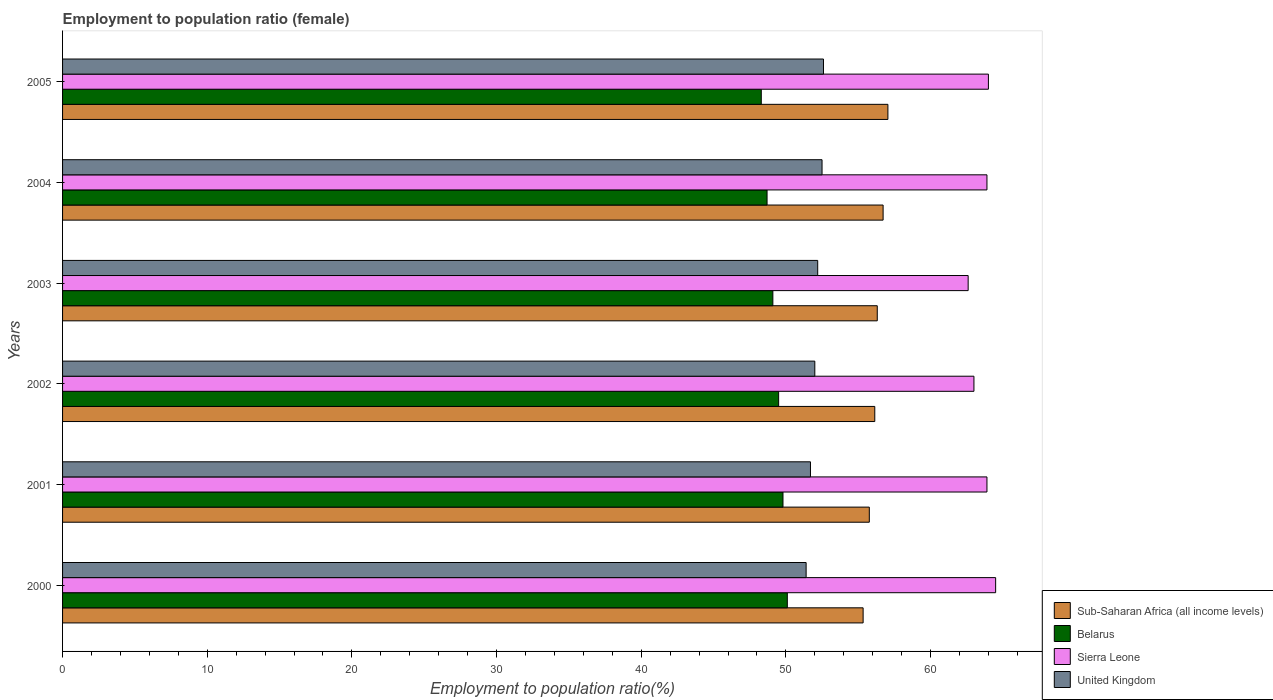Are the number of bars per tick equal to the number of legend labels?
Offer a terse response. Yes. What is the label of the 2nd group of bars from the top?
Your answer should be very brief. 2004. In how many cases, is the number of bars for a given year not equal to the number of legend labels?
Offer a very short reply. 0. What is the employment to population ratio in United Kingdom in 2004?
Give a very brief answer. 52.5. Across all years, what is the maximum employment to population ratio in United Kingdom?
Keep it short and to the point. 52.6. Across all years, what is the minimum employment to population ratio in Belarus?
Your answer should be very brief. 48.3. In which year was the employment to population ratio in Sierra Leone maximum?
Offer a very short reply. 2000. In which year was the employment to population ratio in United Kingdom minimum?
Offer a very short reply. 2000. What is the total employment to population ratio in Sierra Leone in the graph?
Keep it short and to the point. 381.9. What is the difference between the employment to population ratio in Belarus in 2003 and that in 2004?
Your response must be concise. 0.4. What is the difference between the employment to population ratio in United Kingdom in 2004 and the employment to population ratio in Sub-Saharan Africa (all income levels) in 2003?
Provide a succinct answer. -3.82. What is the average employment to population ratio in Sub-Saharan Africa (all income levels) per year?
Keep it short and to the point. 56.22. In the year 2001, what is the difference between the employment to population ratio in Sub-Saharan Africa (all income levels) and employment to population ratio in Sierra Leone?
Your response must be concise. -8.13. What is the ratio of the employment to population ratio in United Kingdom in 2003 to that in 2005?
Provide a short and direct response. 0.99. Is the employment to population ratio in Belarus in 2004 less than that in 2005?
Your answer should be very brief. No. What is the difference between the highest and the second highest employment to population ratio in Sub-Saharan Africa (all income levels)?
Offer a terse response. 0.33. What is the difference between the highest and the lowest employment to population ratio in United Kingdom?
Ensure brevity in your answer.  1.2. Is the sum of the employment to population ratio in Sub-Saharan Africa (all income levels) in 2000 and 2002 greater than the maximum employment to population ratio in United Kingdom across all years?
Your response must be concise. Yes. Is it the case that in every year, the sum of the employment to population ratio in Belarus and employment to population ratio in Sierra Leone is greater than the sum of employment to population ratio in Sub-Saharan Africa (all income levels) and employment to population ratio in United Kingdom?
Keep it short and to the point. No. What does the 2nd bar from the bottom in 2002 represents?
Your answer should be very brief. Belarus. Is it the case that in every year, the sum of the employment to population ratio in United Kingdom and employment to population ratio in Sub-Saharan Africa (all income levels) is greater than the employment to population ratio in Belarus?
Give a very brief answer. Yes. How many years are there in the graph?
Offer a terse response. 6. What is the difference between two consecutive major ticks on the X-axis?
Your response must be concise. 10. Are the values on the major ticks of X-axis written in scientific E-notation?
Offer a terse response. No. Does the graph contain grids?
Keep it short and to the point. No. What is the title of the graph?
Provide a succinct answer. Employment to population ratio (female). What is the label or title of the X-axis?
Your response must be concise. Employment to population ratio(%). What is the label or title of the Y-axis?
Offer a very short reply. Years. What is the Employment to population ratio(%) in Sub-Saharan Africa (all income levels) in 2000?
Provide a succinct answer. 55.34. What is the Employment to population ratio(%) in Belarus in 2000?
Ensure brevity in your answer.  50.1. What is the Employment to population ratio(%) of Sierra Leone in 2000?
Provide a short and direct response. 64.5. What is the Employment to population ratio(%) of United Kingdom in 2000?
Make the answer very short. 51.4. What is the Employment to population ratio(%) of Sub-Saharan Africa (all income levels) in 2001?
Ensure brevity in your answer.  55.77. What is the Employment to population ratio(%) of Belarus in 2001?
Make the answer very short. 49.8. What is the Employment to population ratio(%) in Sierra Leone in 2001?
Provide a succinct answer. 63.9. What is the Employment to population ratio(%) of United Kingdom in 2001?
Offer a terse response. 51.7. What is the Employment to population ratio(%) of Sub-Saharan Africa (all income levels) in 2002?
Make the answer very short. 56.15. What is the Employment to population ratio(%) in Belarus in 2002?
Your response must be concise. 49.5. What is the Employment to population ratio(%) of United Kingdom in 2002?
Offer a terse response. 52. What is the Employment to population ratio(%) in Sub-Saharan Africa (all income levels) in 2003?
Your response must be concise. 56.32. What is the Employment to population ratio(%) in Belarus in 2003?
Make the answer very short. 49.1. What is the Employment to population ratio(%) in Sierra Leone in 2003?
Your answer should be compact. 62.6. What is the Employment to population ratio(%) of United Kingdom in 2003?
Your response must be concise. 52.2. What is the Employment to population ratio(%) of Sub-Saharan Africa (all income levels) in 2004?
Your answer should be very brief. 56.72. What is the Employment to population ratio(%) of Belarus in 2004?
Keep it short and to the point. 48.7. What is the Employment to population ratio(%) in Sierra Leone in 2004?
Make the answer very short. 63.9. What is the Employment to population ratio(%) in United Kingdom in 2004?
Your answer should be very brief. 52.5. What is the Employment to population ratio(%) of Sub-Saharan Africa (all income levels) in 2005?
Your answer should be very brief. 57.05. What is the Employment to population ratio(%) in Belarus in 2005?
Offer a very short reply. 48.3. What is the Employment to population ratio(%) in United Kingdom in 2005?
Your response must be concise. 52.6. Across all years, what is the maximum Employment to population ratio(%) in Sub-Saharan Africa (all income levels)?
Offer a terse response. 57.05. Across all years, what is the maximum Employment to population ratio(%) of Belarus?
Make the answer very short. 50.1. Across all years, what is the maximum Employment to population ratio(%) in Sierra Leone?
Offer a terse response. 64.5. Across all years, what is the maximum Employment to population ratio(%) in United Kingdom?
Keep it short and to the point. 52.6. Across all years, what is the minimum Employment to population ratio(%) of Sub-Saharan Africa (all income levels)?
Make the answer very short. 55.34. Across all years, what is the minimum Employment to population ratio(%) of Belarus?
Your response must be concise. 48.3. Across all years, what is the minimum Employment to population ratio(%) of Sierra Leone?
Offer a terse response. 62.6. Across all years, what is the minimum Employment to population ratio(%) of United Kingdom?
Give a very brief answer. 51.4. What is the total Employment to population ratio(%) in Sub-Saharan Africa (all income levels) in the graph?
Your answer should be very brief. 337.35. What is the total Employment to population ratio(%) in Belarus in the graph?
Give a very brief answer. 295.5. What is the total Employment to population ratio(%) of Sierra Leone in the graph?
Offer a very short reply. 381.9. What is the total Employment to population ratio(%) of United Kingdom in the graph?
Your response must be concise. 312.4. What is the difference between the Employment to population ratio(%) of Sub-Saharan Africa (all income levels) in 2000 and that in 2001?
Make the answer very short. -0.43. What is the difference between the Employment to population ratio(%) of Sub-Saharan Africa (all income levels) in 2000 and that in 2002?
Ensure brevity in your answer.  -0.81. What is the difference between the Employment to population ratio(%) of Belarus in 2000 and that in 2002?
Your answer should be compact. 0.6. What is the difference between the Employment to population ratio(%) of United Kingdom in 2000 and that in 2002?
Provide a succinct answer. -0.6. What is the difference between the Employment to population ratio(%) of Sub-Saharan Africa (all income levels) in 2000 and that in 2003?
Offer a terse response. -0.98. What is the difference between the Employment to population ratio(%) in Sierra Leone in 2000 and that in 2003?
Your answer should be compact. 1.9. What is the difference between the Employment to population ratio(%) of United Kingdom in 2000 and that in 2003?
Give a very brief answer. -0.8. What is the difference between the Employment to population ratio(%) in Sub-Saharan Africa (all income levels) in 2000 and that in 2004?
Your answer should be very brief. -1.38. What is the difference between the Employment to population ratio(%) of Belarus in 2000 and that in 2004?
Offer a very short reply. 1.4. What is the difference between the Employment to population ratio(%) in Sierra Leone in 2000 and that in 2004?
Your response must be concise. 0.6. What is the difference between the Employment to population ratio(%) of United Kingdom in 2000 and that in 2004?
Offer a terse response. -1.1. What is the difference between the Employment to population ratio(%) in Sub-Saharan Africa (all income levels) in 2000 and that in 2005?
Your response must be concise. -1.71. What is the difference between the Employment to population ratio(%) of Belarus in 2000 and that in 2005?
Provide a short and direct response. 1.8. What is the difference between the Employment to population ratio(%) of Sierra Leone in 2000 and that in 2005?
Offer a terse response. 0.5. What is the difference between the Employment to population ratio(%) of United Kingdom in 2000 and that in 2005?
Provide a succinct answer. -1.2. What is the difference between the Employment to population ratio(%) in Sub-Saharan Africa (all income levels) in 2001 and that in 2002?
Offer a very short reply. -0.38. What is the difference between the Employment to population ratio(%) of Sierra Leone in 2001 and that in 2002?
Offer a terse response. 0.9. What is the difference between the Employment to population ratio(%) of Sub-Saharan Africa (all income levels) in 2001 and that in 2003?
Provide a succinct answer. -0.55. What is the difference between the Employment to population ratio(%) of Sierra Leone in 2001 and that in 2003?
Offer a terse response. 1.3. What is the difference between the Employment to population ratio(%) in United Kingdom in 2001 and that in 2003?
Offer a very short reply. -0.5. What is the difference between the Employment to population ratio(%) of Sub-Saharan Africa (all income levels) in 2001 and that in 2004?
Offer a terse response. -0.95. What is the difference between the Employment to population ratio(%) of Sub-Saharan Africa (all income levels) in 2001 and that in 2005?
Provide a short and direct response. -1.29. What is the difference between the Employment to population ratio(%) in Sierra Leone in 2001 and that in 2005?
Provide a short and direct response. -0.1. What is the difference between the Employment to population ratio(%) in Sub-Saharan Africa (all income levels) in 2002 and that in 2003?
Your answer should be very brief. -0.17. What is the difference between the Employment to population ratio(%) of Belarus in 2002 and that in 2003?
Ensure brevity in your answer.  0.4. What is the difference between the Employment to population ratio(%) in United Kingdom in 2002 and that in 2003?
Give a very brief answer. -0.2. What is the difference between the Employment to population ratio(%) in Sub-Saharan Africa (all income levels) in 2002 and that in 2004?
Offer a very short reply. -0.58. What is the difference between the Employment to population ratio(%) in Sierra Leone in 2002 and that in 2004?
Give a very brief answer. -0.9. What is the difference between the Employment to population ratio(%) of United Kingdom in 2002 and that in 2004?
Make the answer very short. -0.5. What is the difference between the Employment to population ratio(%) of Sub-Saharan Africa (all income levels) in 2002 and that in 2005?
Give a very brief answer. -0.91. What is the difference between the Employment to population ratio(%) in Belarus in 2002 and that in 2005?
Your response must be concise. 1.2. What is the difference between the Employment to population ratio(%) in Sub-Saharan Africa (all income levels) in 2003 and that in 2004?
Make the answer very short. -0.4. What is the difference between the Employment to population ratio(%) in Belarus in 2003 and that in 2004?
Provide a short and direct response. 0.4. What is the difference between the Employment to population ratio(%) in Sub-Saharan Africa (all income levels) in 2003 and that in 2005?
Make the answer very short. -0.74. What is the difference between the Employment to population ratio(%) in Sierra Leone in 2003 and that in 2005?
Ensure brevity in your answer.  -1.4. What is the difference between the Employment to population ratio(%) of Sub-Saharan Africa (all income levels) in 2004 and that in 2005?
Offer a terse response. -0.33. What is the difference between the Employment to population ratio(%) of United Kingdom in 2004 and that in 2005?
Make the answer very short. -0.1. What is the difference between the Employment to population ratio(%) in Sub-Saharan Africa (all income levels) in 2000 and the Employment to population ratio(%) in Belarus in 2001?
Ensure brevity in your answer.  5.54. What is the difference between the Employment to population ratio(%) in Sub-Saharan Africa (all income levels) in 2000 and the Employment to population ratio(%) in Sierra Leone in 2001?
Offer a terse response. -8.56. What is the difference between the Employment to population ratio(%) in Sub-Saharan Africa (all income levels) in 2000 and the Employment to population ratio(%) in United Kingdom in 2001?
Ensure brevity in your answer.  3.64. What is the difference between the Employment to population ratio(%) of Sub-Saharan Africa (all income levels) in 2000 and the Employment to population ratio(%) of Belarus in 2002?
Keep it short and to the point. 5.84. What is the difference between the Employment to population ratio(%) in Sub-Saharan Africa (all income levels) in 2000 and the Employment to population ratio(%) in Sierra Leone in 2002?
Offer a very short reply. -7.66. What is the difference between the Employment to population ratio(%) of Sub-Saharan Africa (all income levels) in 2000 and the Employment to population ratio(%) of United Kingdom in 2002?
Offer a terse response. 3.34. What is the difference between the Employment to population ratio(%) in Belarus in 2000 and the Employment to population ratio(%) in Sierra Leone in 2002?
Keep it short and to the point. -12.9. What is the difference between the Employment to population ratio(%) in Belarus in 2000 and the Employment to population ratio(%) in United Kingdom in 2002?
Give a very brief answer. -1.9. What is the difference between the Employment to population ratio(%) in Sierra Leone in 2000 and the Employment to population ratio(%) in United Kingdom in 2002?
Offer a terse response. 12.5. What is the difference between the Employment to population ratio(%) in Sub-Saharan Africa (all income levels) in 2000 and the Employment to population ratio(%) in Belarus in 2003?
Your answer should be compact. 6.24. What is the difference between the Employment to population ratio(%) in Sub-Saharan Africa (all income levels) in 2000 and the Employment to population ratio(%) in Sierra Leone in 2003?
Your response must be concise. -7.26. What is the difference between the Employment to population ratio(%) in Sub-Saharan Africa (all income levels) in 2000 and the Employment to population ratio(%) in United Kingdom in 2003?
Ensure brevity in your answer.  3.14. What is the difference between the Employment to population ratio(%) in Sierra Leone in 2000 and the Employment to population ratio(%) in United Kingdom in 2003?
Your answer should be very brief. 12.3. What is the difference between the Employment to population ratio(%) of Sub-Saharan Africa (all income levels) in 2000 and the Employment to population ratio(%) of Belarus in 2004?
Ensure brevity in your answer.  6.64. What is the difference between the Employment to population ratio(%) in Sub-Saharan Africa (all income levels) in 2000 and the Employment to population ratio(%) in Sierra Leone in 2004?
Offer a terse response. -8.56. What is the difference between the Employment to population ratio(%) in Sub-Saharan Africa (all income levels) in 2000 and the Employment to population ratio(%) in United Kingdom in 2004?
Make the answer very short. 2.84. What is the difference between the Employment to population ratio(%) in Sub-Saharan Africa (all income levels) in 2000 and the Employment to population ratio(%) in Belarus in 2005?
Offer a very short reply. 7.04. What is the difference between the Employment to population ratio(%) of Sub-Saharan Africa (all income levels) in 2000 and the Employment to population ratio(%) of Sierra Leone in 2005?
Your answer should be very brief. -8.66. What is the difference between the Employment to population ratio(%) in Sub-Saharan Africa (all income levels) in 2000 and the Employment to population ratio(%) in United Kingdom in 2005?
Keep it short and to the point. 2.74. What is the difference between the Employment to population ratio(%) of Belarus in 2000 and the Employment to population ratio(%) of Sierra Leone in 2005?
Your response must be concise. -13.9. What is the difference between the Employment to population ratio(%) of Sierra Leone in 2000 and the Employment to population ratio(%) of United Kingdom in 2005?
Make the answer very short. 11.9. What is the difference between the Employment to population ratio(%) of Sub-Saharan Africa (all income levels) in 2001 and the Employment to population ratio(%) of Belarus in 2002?
Keep it short and to the point. 6.27. What is the difference between the Employment to population ratio(%) of Sub-Saharan Africa (all income levels) in 2001 and the Employment to population ratio(%) of Sierra Leone in 2002?
Ensure brevity in your answer.  -7.23. What is the difference between the Employment to population ratio(%) of Sub-Saharan Africa (all income levels) in 2001 and the Employment to population ratio(%) of United Kingdom in 2002?
Make the answer very short. 3.77. What is the difference between the Employment to population ratio(%) of Belarus in 2001 and the Employment to population ratio(%) of Sierra Leone in 2002?
Offer a terse response. -13.2. What is the difference between the Employment to population ratio(%) in Sierra Leone in 2001 and the Employment to population ratio(%) in United Kingdom in 2002?
Offer a terse response. 11.9. What is the difference between the Employment to population ratio(%) of Sub-Saharan Africa (all income levels) in 2001 and the Employment to population ratio(%) of Belarus in 2003?
Keep it short and to the point. 6.67. What is the difference between the Employment to population ratio(%) in Sub-Saharan Africa (all income levels) in 2001 and the Employment to population ratio(%) in Sierra Leone in 2003?
Your answer should be very brief. -6.83. What is the difference between the Employment to population ratio(%) in Sub-Saharan Africa (all income levels) in 2001 and the Employment to population ratio(%) in United Kingdom in 2003?
Offer a terse response. 3.57. What is the difference between the Employment to population ratio(%) in Belarus in 2001 and the Employment to population ratio(%) in Sierra Leone in 2003?
Provide a short and direct response. -12.8. What is the difference between the Employment to population ratio(%) of Sierra Leone in 2001 and the Employment to population ratio(%) of United Kingdom in 2003?
Offer a terse response. 11.7. What is the difference between the Employment to population ratio(%) in Sub-Saharan Africa (all income levels) in 2001 and the Employment to population ratio(%) in Belarus in 2004?
Provide a succinct answer. 7.07. What is the difference between the Employment to population ratio(%) of Sub-Saharan Africa (all income levels) in 2001 and the Employment to population ratio(%) of Sierra Leone in 2004?
Offer a terse response. -8.13. What is the difference between the Employment to population ratio(%) of Sub-Saharan Africa (all income levels) in 2001 and the Employment to population ratio(%) of United Kingdom in 2004?
Ensure brevity in your answer.  3.27. What is the difference between the Employment to population ratio(%) in Belarus in 2001 and the Employment to population ratio(%) in Sierra Leone in 2004?
Your answer should be very brief. -14.1. What is the difference between the Employment to population ratio(%) in Belarus in 2001 and the Employment to population ratio(%) in United Kingdom in 2004?
Your response must be concise. -2.7. What is the difference between the Employment to population ratio(%) of Sierra Leone in 2001 and the Employment to population ratio(%) of United Kingdom in 2004?
Your answer should be very brief. 11.4. What is the difference between the Employment to population ratio(%) in Sub-Saharan Africa (all income levels) in 2001 and the Employment to population ratio(%) in Belarus in 2005?
Make the answer very short. 7.47. What is the difference between the Employment to population ratio(%) of Sub-Saharan Africa (all income levels) in 2001 and the Employment to population ratio(%) of Sierra Leone in 2005?
Offer a very short reply. -8.23. What is the difference between the Employment to population ratio(%) in Sub-Saharan Africa (all income levels) in 2001 and the Employment to population ratio(%) in United Kingdom in 2005?
Offer a terse response. 3.17. What is the difference between the Employment to population ratio(%) of Belarus in 2001 and the Employment to population ratio(%) of Sierra Leone in 2005?
Make the answer very short. -14.2. What is the difference between the Employment to population ratio(%) in Sub-Saharan Africa (all income levels) in 2002 and the Employment to population ratio(%) in Belarus in 2003?
Your response must be concise. 7.05. What is the difference between the Employment to population ratio(%) of Sub-Saharan Africa (all income levels) in 2002 and the Employment to population ratio(%) of Sierra Leone in 2003?
Offer a terse response. -6.45. What is the difference between the Employment to population ratio(%) in Sub-Saharan Africa (all income levels) in 2002 and the Employment to population ratio(%) in United Kingdom in 2003?
Your answer should be very brief. 3.95. What is the difference between the Employment to population ratio(%) in Sub-Saharan Africa (all income levels) in 2002 and the Employment to population ratio(%) in Belarus in 2004?
Your answer should be compact. 7.45. What is the difference between the Employment to population ratio(%) in Sub-Saharan Africa (all income levels) in 2002 and the Employment to population ratio(%) in Sierra Leone in 2004?
Give a very brief answer. -7.75. What is the difference between the Employment to population ratio(%) of Sub-Saharan Africa (all income levels) in 2002 and the Employment to population ratio(%) of United Kingdom in 2004?
Give a very brief answer. 3.65. What is the difference between the Employment to population ratio(%) in Belarus in 2002 and the Employment to population ratio(%) in Sierra Leone in 2004?
Your answer should be compact. -14.4. What is the difference between the Employment to population ratio(%) of Belarus in 2002 and the Employment to population ratio(%) of United Kingdom in 2004?
Provide a short and direct response. -3. What is the difference between the Employment to population ratio(%) of Sub-Saharan Africa (all income levels) in 2002 and the Employment to population ratio(%) of Belarus in 2005?
Provide a succinct answer. 7.85. What is the difference between the Employment to population ratio(%) in Sub-Saharan Africa (all income levels) in 2002 and the Employment to population ratio(%) in Sierra Leone in 2005?
Provide a succinct answer. -7.85. What is the difference between the Employment to population ratio(%) in Sub-Saharan Africa (all income levels) in 2002 and the Employment to population ratio(%) in United Kingdom in 2005?
Ensure brevity in your answer.  3.55. What is the difference between the Employment to population ratio(%) in Sierra Leone in 2002 and the Employment to population ratio(%) in United Kingdom in 2005?
Your answer should be very brief. 10.4. What is the difference between the Employment to population ratio(%) in Sub-Saharan Africa (all income levels) in 2003 and the Employment to population ratio(%) in Belarus in 2004?
Ensure brevity in your answer.  7.62. What is the difference between the Employment to population ratio(%) in Sub-Saharan Africa (all income levels) in 2003 and the Employment to population ratio(%) in Sierra Leone in 2004?
Provide a succinct answer. -7.58. What is the difference between the Employment to population ratio(%) of Sub-Saharan Africa (all income levels) in 2003 and the Employment to population ratio(%) of United Kingdom in 2004?
Provide a succinct answer. 3.82. What is the difference between the Employment to population ratio(%) of Belarus in 2003 and the Employment to population ratio(%) of Sierra Leone in 2004?
Make the answer very short. -14.8. What is the difference between the Employment to population ratio(%) of Belarus in 2003 and the Employment to population ratio(%) of United Kingdom in 2004?
Ensure brevity in your answer.  -3.4. What is the difference between the Employment to population ratio(%) in Sierra Leone in 2003 and the Employment to population ratio(%) in United Kingdom in 2004?
Keep it short and to the point. 10.1. What is the difference between the Employment to population ratio(%) of Sub-Saharan Africa (all income levels) in 2003 and the Employment to population ratio(%) of Belarus in 2005?
Keep it short and to the point. 8.02. What is the difference between the Employment to population ratio(%) in Sub-Saharan Africa (all income levels) in 2003 and the Employment to population ratio(%) in Sierra Leone in 2005?
Provide a short and direct response. -7.68. What is the difference between the Employment to population ratio(%) in Sub-Saharan Africa (all income levels) in 2003 and the Employment to population ratio(%) in United Kingdom in 2005?
Offer a very short reply. 3.72. What is the difference between the Employment to population ratio(%) of Belarus in 2003 and the Employment to population ratio(%) of Sierra Leone in 2005?
Offer a very short reply. -14.9. What is the difference between the Employment to population ratio(%) in Belarus in 2003 and the Employment to population ratio(%) in United Kingdom in 2005?
Ensure brevity in your answer.  -3.5. What is the difference between the Employment to population ratio(%) in Sub-Saharan Africa (all income levels) in 2004 and the Employment to population ratio(%) in Belarus in 2005?
Make the answer very short. 8.42. What is the difference between the Employment to population ratio(%) in Sub-Saharan Africa (all income levels) in 2004 and the Employment to population ratio(%) in Sierra Leone in 2005?
Offer a very short reply. -7.28. What is the difference between the Employment to population ratio(%) of Sub-Saharan Africa (all income levels) in 2004 and the Employment to population ratio(%) of United Kingdom in 2005?
Your response must be concise. 4.12. What is the difference between the Employment to population ratio(%) in Belarus in 2004 and the Employment to population ratio(%) in Sierra Leone in 2005?
Give a very brief answer. -15.3. What is the difference between the Employment to population ratio(%) in Sierra Leone in 2004 and the Employment to population ratio(%) in United Kingdom in 2005?
Give a very brief answer. 11.3. What is the average Employment to population ratio(%) in Sub-Saharan Africa (all income levels) per year?
Your answer should be compact. 56.22. What is the average Employment to population ratio(%) in Belarus per year?
Keep it short and to the point. 49.25. What is the average Employment to population ratio(%) in Sierra Leone per year?
Provide a short and direct response. 63.65. What is the average Employment to population ratio(%) of United Kingdom per year?
Give a very brief answer. 52.07. In the year 2000, what is the difference between the Employment to population ratio(%) in Sub-Saharan Africa (all income levels) and Employment to population ratio(%) in Belarus?
Keep it short and to the point. 5.24. In the year 2000, what is the difference between the Employment to population ratio(%) in Sub-Saharan Africa (all income levels) and Employment to population ratio(%) in Sierra Leone?
Ensure brevity in your answer.  -9.16. In the year 2000, what is the difference between the Employment to population ratio(%) of Sub-Saharan Africa (all income levels) and Employment to population ratio(%) of United Kingdom?
Your answer should be compact. 3.94. In the year 2000, what is the difference between the Employment to population ratio(%) in Belarus and Employment to population ratio(%) in Sierra Leone?
Your response must be concise. -14.4. In the year 2001, what is the difference between the Employment to population ratio(%) of Sub-Saharan Africa (all income levels) and Employment to population ratio(%) of Belarus?
Give a very brief answer. 5.97. In the year 2001, what is the difference between the Employment to population ratio(%) of Sub-Saharan Africa (all income levels) and Employment to population ratio(%) of Sierra Leone?
Ensure brevity in your answer.  -8.13. In the year 2001, what is the difference between the Employment to population ratio(%) in Sub-Saharan Africa (all income levels) and Employment to population ratio(%) in United Kingdom?
Give a very brief answer. 4.07. In the year 2001, what is the difference between the Employment to population ratio(%) of Belarus and Employment to population ratio(%) of Sierra Leone?
Make the answer very short. -14.1. In the year 2002, what is the difference between the Employment to population ratio(%) in Sub-Saharan Africa (all income levels) and Employment to population ratio(%) in Belarus?
Your answer should be very brief. 6.65. In the year 2002, what is the difference between the Employment to population ratio(%) of Sub-Saharan Africa (all income levels) and Employment to population ratio(%) of Sierra Leone?
Your response must be concise. -6.85. In the year 2002, what is the difference between the Employment to population ratio(%) of Sub-Saharan Africa (all income levels) and Employment to population ratio(%) of United Kingdom?
Your answer should be very brief. 4.15. In the year 2002, what is the difference between the Employment to population ratio(%) in Belarus and Employment to population ratio(%) in Sierra Leone?
Provide a short and direct response. -13.5. In the year 2003, what is the difference between the Employment to population ratio(%) of Sub-Saharan Africa (all income levels) and Employment to population ratio(%) of Belarus?
Offer a very short reply. 7.22. In the year 2003, what is the difference between the Employment to population ratio(%) of Sub-Saharan Africa (all income levels) and Employment to population ratio(%) of Sierra Leone?
Offer a terse response. -6.28. In the year 2003, what is the difference between the Employment to population ratio(%) of Sub-Saharan Africa (all income levels) and Employment to population ratio(%) of United Kingdom?
Your response must be concise. 4.12. In the year 2003, what is the difference between the Employment to population ratio(%) of Belarus and Employment to population ratio(%) of Sierra Leone?
Give a very brief answer. -13.5. In the year 2004, what is the difference between the Employment to population ratio(%) in Sub-Saharan Africa (all income levels) and Employment to population ratio(%) in Belarus?
Your response must be concise. 8.02. In the year 2004, what is the difference between the Employment to population ratio(%) of Sub-Saharan Africa (all income levels) and Employment to population ratio(%) of Sierra Leone?
Keep it short and to the point. -7.18. In the year 2004, what is the difference between the Employment to population ratio(%) of Sub-Saharan Africa (all income levels) and Employment to population ratio(%) of United Kingdom?
Offer a terse response. 4.22. In the year 2004, what is the difference between the Employment to population ratio(%) of Belarus and Employment to population ratio(%) of Sierra Leone?
Provide a succinct answer. -15.2. In the year 2004, what is the difference between the Employment to population ratio(%) in Belarus and Employment to population ratio(%) in United Kingdom?
Provide a succinct answer. -3.8. In the year 2004, what is the difference between the Employment to population ratio(%) of Sierra Leone and Employment to population ratio(%) of United Kingdom?
Offer a terse response. 11.4. In the year 2005, what is the difference between the Employment to population ratio(%) in Sub-Saharan Africa (all income levels) and Employment to population ratio(%) in Belarus?
Offer a terse response. 8.75. In the year 2005, what is the difference between the Employment to population ratio(%) in Sub-Saharan Africa (all income levels) and Employment to population ratio(%) in Sierra Leone?
Keep it short and to the point. -6.95. In the year 2005, what is the difference between the Employment to population ratio(%) of Sub-Saharan Africa (all income levels) and Employment to population ratio(%) of United Kingdom?
Ensure brevity in your answer.  4.45. In the year 2005, what is the difference between the Employment to population ratio(%) in Belarus and Employment to population ratio(%) in Sierra Leone?
Provide a short and direct response. -15.7. In the year 2005, what is the difference between the Employment to population ratio(%) in Belarus and Employment to population ratio(%) in United Kingdom?
Give a very brief answer. -4.3. What is the ratio of the Employment to population ratio(%) in Sub-Saharan Africa (all income levels) in 2000 to that in 2001?
Your response must be concise. 0.99. What is the ratio of the Employment to population ratio(%) of Sierra Leone in 2000 to that in 2001?
Offer a very short reply. 1.01. What is the ratio of the Employment to population ratio(%) in Sub-Saharan Africa (all income levels) in 2000 to that in 2002?
Keep it short and to the point. 0.99. What is the ratio of the Employment to population ratio(%) in Belarus in 2000 to that in 2002?
Provide a succinct answer. 1.01. What is the ratio of the Employment to population ratio(%) in Sierra Leone in 2000 to that in 2002?
Your answer should be compact. 1.02. What is the ratio of the Employment to population ratio(%) of United Kingdom in 2000 to that in 2002?
Provide a short and direct response. 0.99. What is the ratio of the Employment to population ratio(%) of Sub-Saharan Africa (all income levels) in 2000 to that in 2003?
Keep it short and to the point. 0.98. What is the ratio of the Employment to population ratio(%) in Belarus in 2000 to that in 2003?
Offer a terse response. 1.02. What is the ratio of the Employment to population ratio(%) in Sierra Leone in 2000 to that in 2003?
Provide a short and direct response. 1.03. What is the ratio of the Employment to population ratio(%) in United Kingdom in 2000 to that in 2003?
Your answer should be very brief. 0.98. What is the ratio of the Employment to population ratio(%) of Sub-Saharan Africa (all income levels) in 2000 to that in 2004?
Your answer should be very brief. 0.98. What is the ratio of the Employment to population ratio(%) of Belarus in 2000 to that in 2004?
Give a very brief answer. 1.03. What is the ratio of the Employment to population ratio(%) of Sierra Leone in 2000 to that in 2004?
Keep it short and to the point. 1.01. What is the ratio of the Employment to population ratio(%) in United Kingdom in 2000 to that in 2004?
Ensure brevity in your answer.  0.98. What is the ratio of the Employment to population ratio(%) of Belarus in 2000 to that in 2005?
Your answer should be very brief. 1.04. What is the ratio of the Employment to population ratio(%) of Sierra Leone in 2000 to that in 2005?
Your response must be concise. 1.01. What is the ratio of the Employment to population ratio(%) in United Kingdom in 2000 to that in 2005?
Offer a terse response. 0.98. What is the ratio of the Employment to population ratio(%) of Belarus in 2001 to that in 2002?
Ensure brevity in your answer.  1.01. What is the ratio of the Employment to population ratio(%) of Sierra Leone in 2001 to that in 2002?
Give a very brief answer. 1.01. What is the ratio of the Employment to population ratio(%) in Sub-Saharan Africa (all income levels) in 2001 to that in 2003?
Your response must be concise. 0.99. What is the ratio of the Employment to population ratio(%) in Belarus in 2001 to that in 2003?
Provide a short and direct response. 1.01. What is the ratio of the Employment to population ratio(%) in Sierra Leone in 2001 to that in 2003?
Provide a succinct answer. 1.02. What is the ratio of the Employment to population ratio(%) of United Kingdom in 2001 to that in 2003?
Keep it short and to the point. 0.99. What is the ratio of the Employment to population ratio(%) in Sub-Saharan Africa (all income levels) in 2001 to that in 2004?
Make the answer very short. 0.98. What is the ratio of the Employment to population ratio(%) in Belarus in 2001 to that in 2004?
Make the answer very short. 1.02. What is the ratio of the Employment to population ratio(%) in Sierra Leone in 2001 to that in 2004?
Provide a short and direct response. 1. What is the ratio of the Employment to population ratio(%) in Sub-Saharan Africa (all income levels) in 2001 to that in 2005?
Your answer should be very brief. 0.98. What is the ratio of the Employment to population ratio(%) of Belarus in 2001 to that in 2005?
Your answer should be compact. 1.03. What is the ratio of the Employment to population ratio(%) of Sierra Leone in 2001 to that in 2005?
Offer a very short reply. 1. What is the ratio of the Employment to population ratio(%) of United Kingdom in 2001 to that in 2005?
Ensure brevity in your answer.  0.98. What is the ratio of the Employment to population ratio(%) in Sub-Saharan Africa (all income levels) in 2002 to that in 2003?
Give a very brief answer. 1. What is the ratio of the Employment to population ratio(%) of Belarus in 2002 to that in 2003?
Your answer should be very brief. 1.01. What is the ratio of the Employment to population ratio(%) in Sierra Leone in 2002 to that in 2003?
Offer a terse response. 1.01. What is the ratio of the Employment to population ratio(%) in United Kingdom in 2002 to that in 2003?
Your answer should be compact. 1. What is the ratio of the Employment to population ratio(%) of Belarus in 2002 to that in 2004?
Make the answer very short. 1.02. What is the ratio of the Employment to population ratio(%) in Sierra Leone in 2002 to that in 2004?
Your answer should be compact. 0.99. What is the ratio of the Employment to population ratio(%) in Sub-Saharan Africa (all income levels) in 2002 to that in 2005?
Keep it short and to the point. 0.98. What is the ratio of the Employment to population ratio(%) of Belarus in 2002 to that in 2005?
Your response must be concise. 1.02. What is the ratio of the Employment to population ratio(%) of Sierra Leone in 2002 to that in 2005?
Ensure brevity in your answer.  0.98. What is the ratio of the Employment to population ratio(%) of United Kingdom in 2002 to that in 2005?
Keep it short and to the point. 0.99. What is the ratio of the Employment to population ratio(%) in Sub-Saharan Africa (all income levels) in 2003 to that in 2004?
Provide a short and direct response. 0.99. What is the ratio of the Employment to population ratio(%) in Belarus in 2003 to that in 2004?
Ensure brevity in your answer.  1.01. What is the ratio of the Employment to population ratio(%) in Sierra Leone in 2003 to that in 2004?
Keep it short and to the point. 0.98. What is the ratio of the Employment to population ratio(%) of United Kingdom in 2003 to that in 2004?
Provide a succinct answer. 0.99. What is the ratio of the Employment to population ratio(%) of Sub-Saharan Africa (all income levels) in 2003 to that in 2005?
Your response must be concise. 0.99. What is the ratio of the Employment to population ratio(%) of Belarus in 2003 to that in 2005?
Make the answer very short. 1.02. What is the ratio of the Employment to population ratio(%) in Sierra Leone in 2003 to that in 2005?
Provide a short and direct response. 0.98. What is the ratio of the Employment to population ratio(%) of United Kingdom in 2003 to that in 2005?
Ensure brevity in your answer.  0.99. What is the ratio of the Employment to population ratio(%) in Sub-Saharan Africa (all income levels) in 2004 to that in 2005?
Provide a succinct answer. 0.99. What is the ratio of the Employment to population ratio(%) of Belarus in 2004 to that in 2005?
Your answer should be very brief. 1.01. What is the ratio of the Employment to population ratio(%) of Sierra Leone in 2004 to that in 2005?
Keep it short and to the point. 1. What is the ratio of the Employment to population ratio(%) in United Kingdom in 2004 to that in 2005?
Ensure brevity in your answer.  1. What is the difference between the highest and the second highest Employment to population ratio(%) in Sub-Saharan Africa (all income levels)?
Provide a short and direct response. 0.33. What is the difference between the highest and the second highest Employment to population ratio(%) in United Kingdom?
Make the answer very short. 0.1. What is the difference between the highest and the lowest Employment to population ratio(%) of Sub-Saharan Africa (all income levels)?
Your answer should be very brief. 1.71. What is the difference between the highest and the lowest Employment to population ratio(%) of Belarus?
Make the answer very short. 1.8. What is the difference between the highest and the lowest Employment to population ratio(%) of United Kingdom?
Provide a short and direct response. 1.2. 